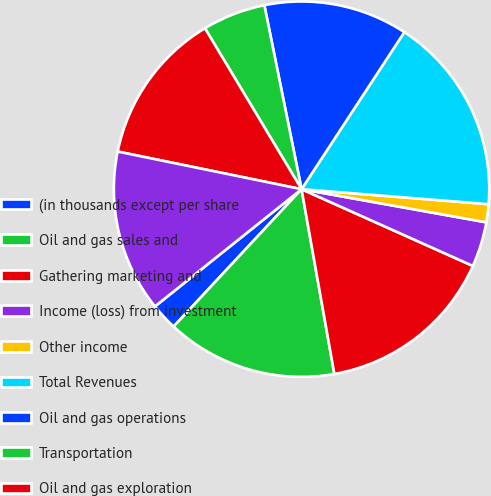Convert chart to OTSL. <chart><loc_0><loc_0><loc_500><loc_500><pie_chart><fcel>(in thousands except per share<fcel>Oil and gas sales and<fcel>Gathering marketing and<fcel>Income (loss) from investment<fcel>Other income<fcel>Total Revenues<fcel>Oil and gas operations<fcel>Transportation<fcel>Oil and gas exploration<fcel>Depreciation depletion and<nl><fcel>2.33%<fcel>14.73%<fcel>15.5%<fcel>3.88%<fcel>1.55%<fcel>17.05%<fcel>12.4%<fcel>5.43%<fcel>13.18%<fcel>13.95%<nl></chart> 